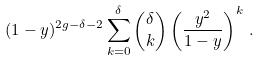Convert formula to latex. <formula><loc_0><loc_0><loc_500><loc_500>( 1 - y ) ^ { 2 g - \delta - 2 } \sum _ { k = 0 } ^ { \delta } \binom { \delta } { k } \left ( \frac { y ^ { 2 } } { 1 - y } \right ) ^ { k } \, .</formula> 